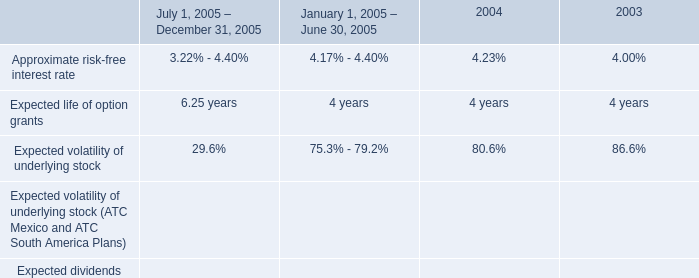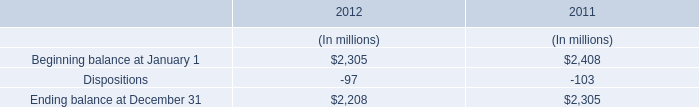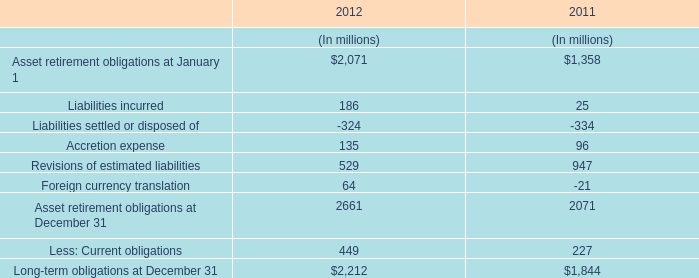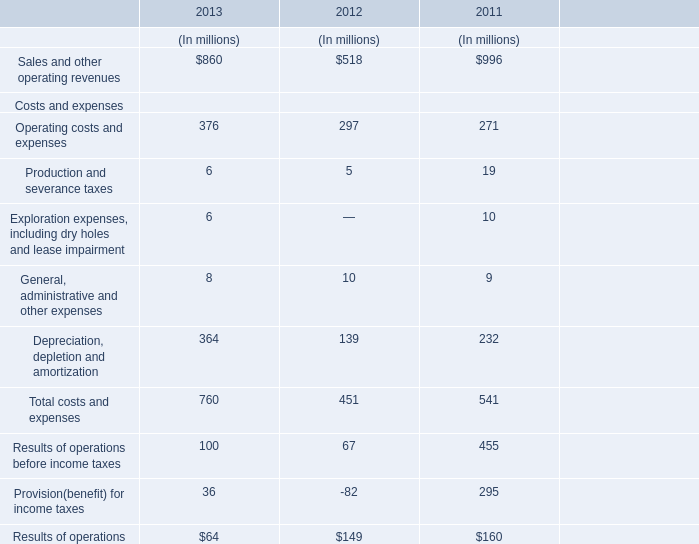Which year is the Sales and other operating revenues the least? 
Answer: 2012. 